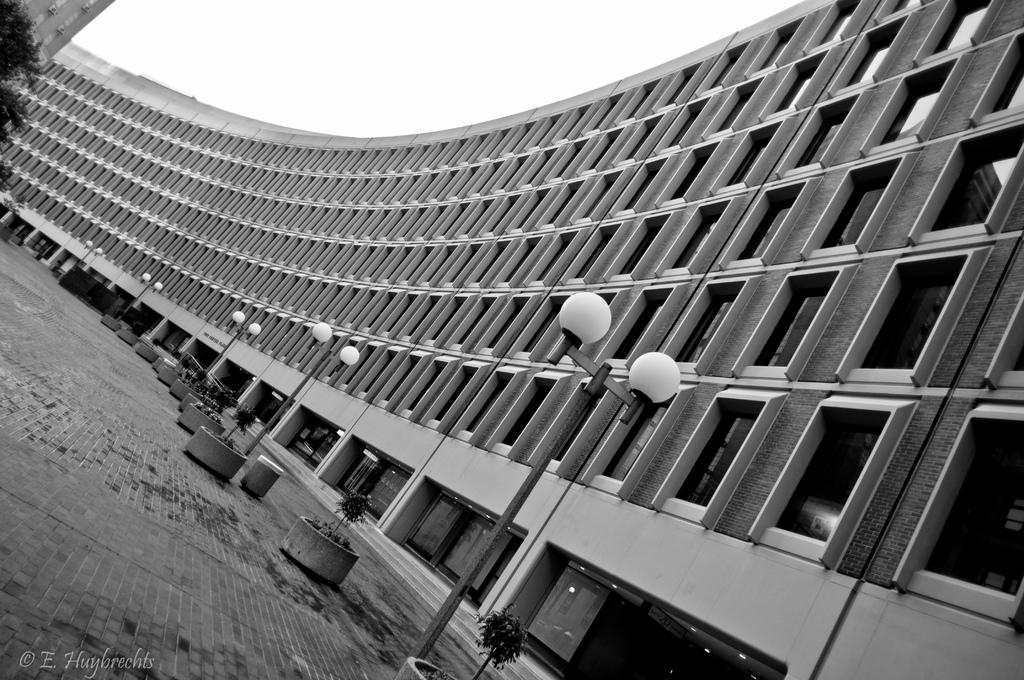What type of structure is present in the image? There is a building in the image. What feature can be observed on the building? The building has glass windows. What is located in front of the building? There are light-poles and trees in front of the building. What decorative items are present on the floor? There are flower pots on the floor. How is the image presented? The image is in black and white. What type of nose can be seen on the jeans in the image? There is no nose or jeans present in the image; it features a building with glass windows, light-poles, trees, and flower pots. 